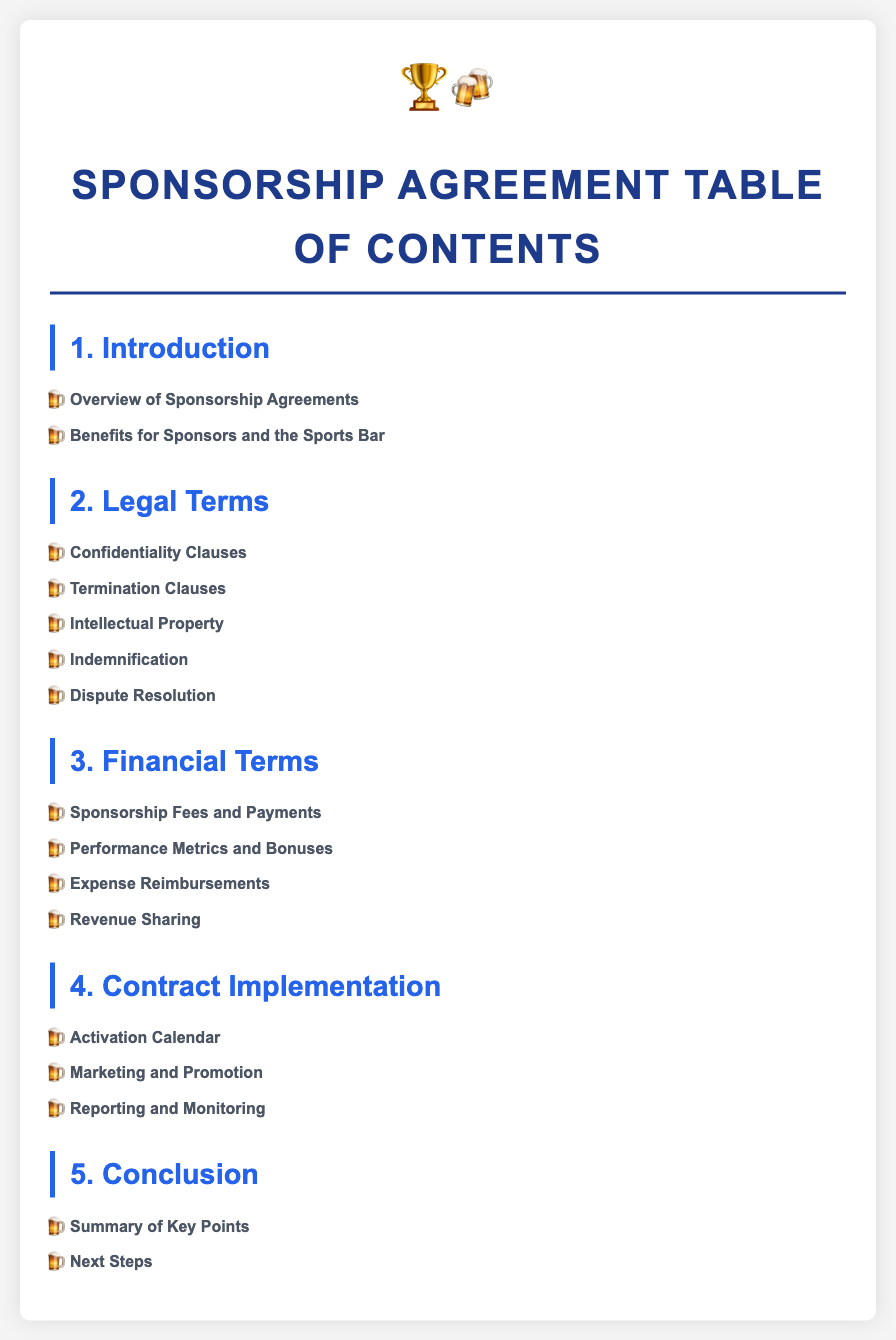what is the first section of the table of contents? The first section outlines the basics of sponsorship agreements.
Answer: Introduction how many legal terms are listed in the document? The document includes five legal terms relevant to sponsorship agreements.
Answer: five which subsection discusses protecting sensitive information? This subsection addresses how confidentiality is maintained in sponsorship agreements.
Answer: Confidentiality Clauses what is included in the financial terms section? This section covers details about sponsorship fees, performance metrics, reimbursement policies, and revenue sharing.
Answer: Sponsorship Fees and Payments, Performance Metrics and Bonuses, Expense Reimbursements, Revenue Sharing what does the activation calendar outline? It specifies the timeline and key dates for when the sponsorship will be activated.
Answer: Timeline and key dates what is the purpose of the conclusion section? This section recaps important points and sets the stage for future actions related to the agreement.
Answer: Summary of Key Points, Next Steps 